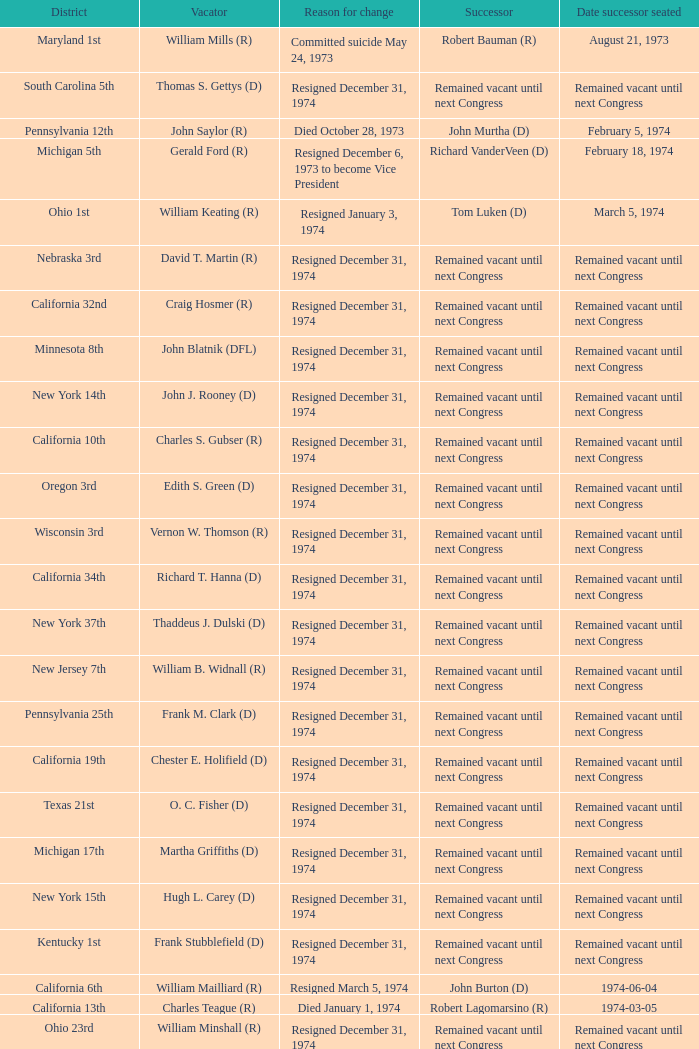Who was the successor when the vacator was chester e. holifield (d)? Remained vacant until next Congress. 